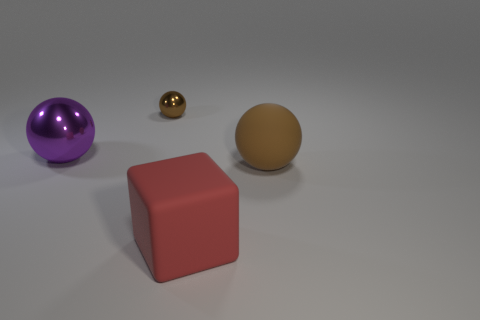There is a rubber thing that is on the right side of the red matte thing; is its size the same as the tiny ball?
Your answer should be compact. No. There is a brown object in front of the brown metallic object; what material is it?
Offer a very short reply. Rubber. Is the number of brown metal balls greater than the number of brown spheres?
Ensure brevity in your answer.  No. How many objects are either balls on the right side of the brown metallic thing or green metallic spheres?
Keep it short and to the point. 1. How many large things are on the left side of the brown matte ball that is in front of the purple thing?
Offer a terse response. 2. What is the size of the brown thing that is on the left side of the rubber object that is in front of the big ball that is to the right of the small brown thing?
Ensure brevity in your answer.  Small. There is a thing in front of the large brown thing; does it have the same color as the large matte ball?
Your response must be concise. No. There is a rubber object that is the same shape as the big shiny object; what size is it?
Make the answer very short. Large. What number of things are either brown balls on the right side of the block or rubber objects right of the big block?
Give a very brief answer. 1. What is the shape of the metallic thing behind the metallic ball in front of the brown metallic thing?
Your answer should be very brief. Sphere. 